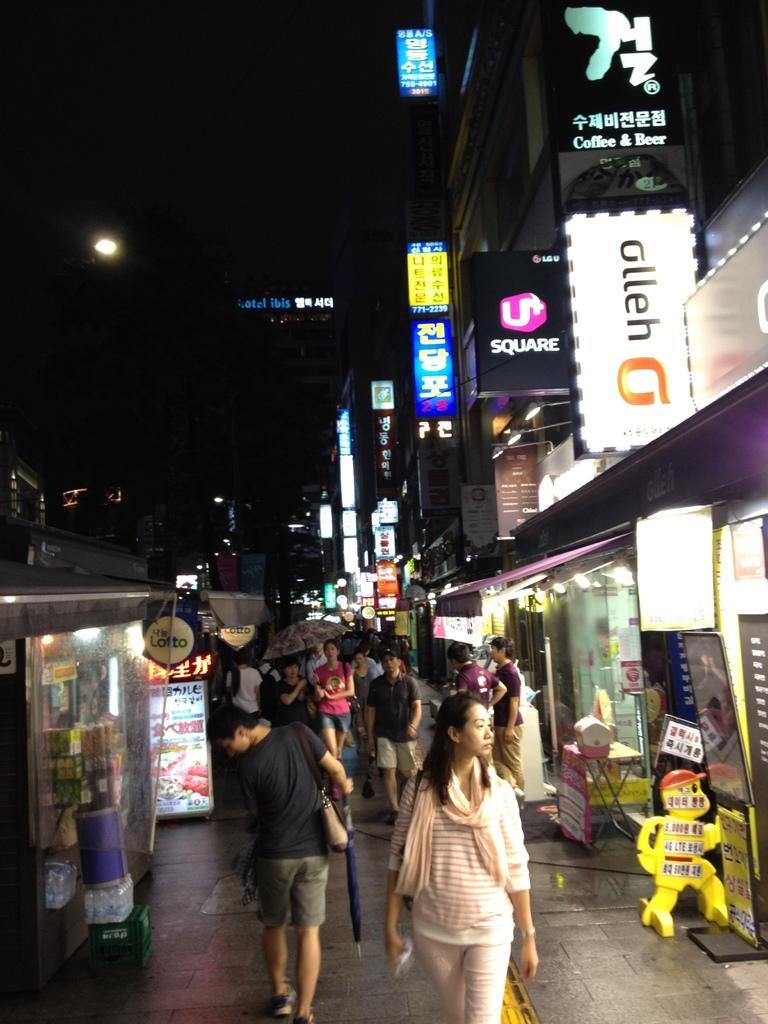Could you give a brief overview of what you see in this image? In this image we can see a street. There are many people walking. Few are holding umbrellas. On the sides there are shops. Also there are banners with shops. There are lights. In the background it is dark. 